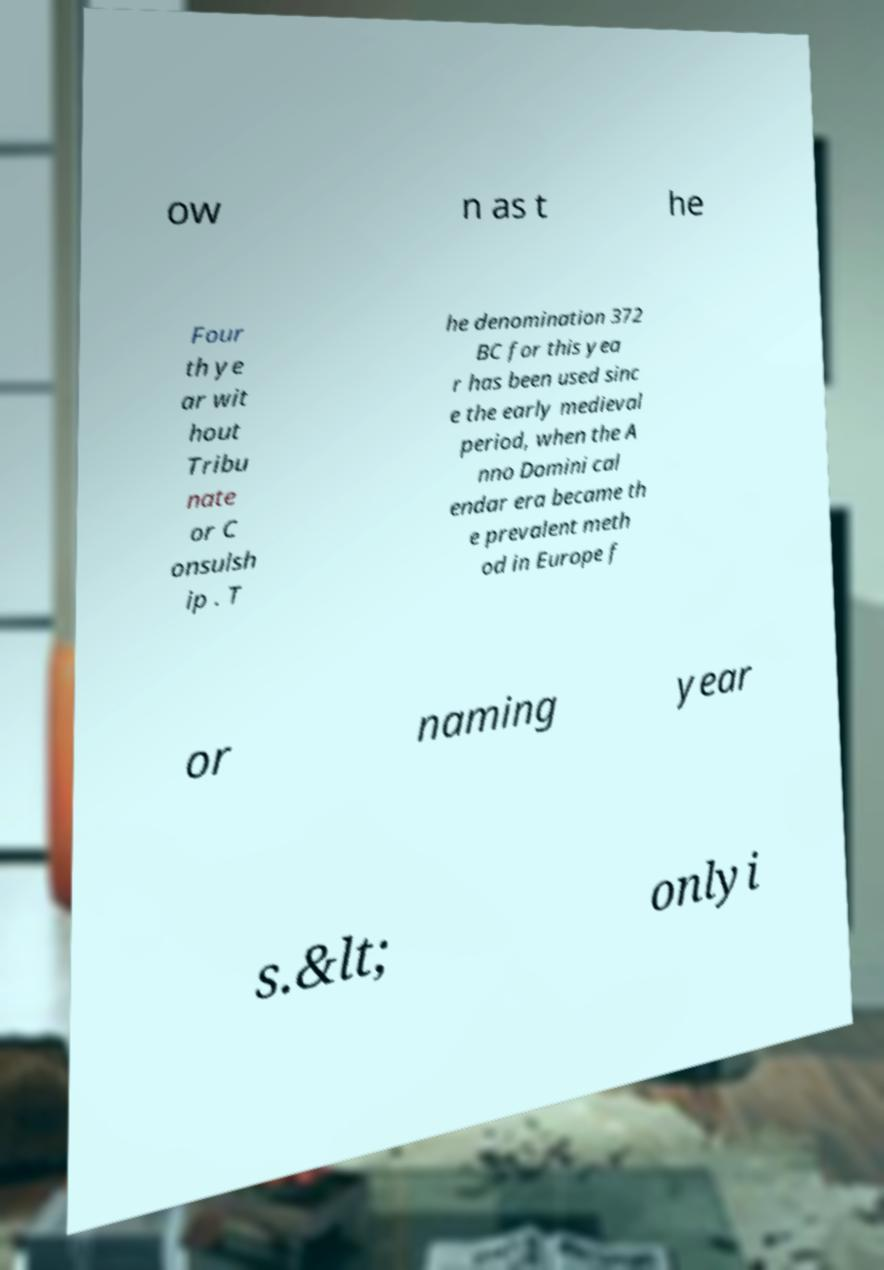I need the written content from this picture converted into text. Can you do that? ow n as t he Four th ye ar wit hout Tribu nate or C onsulsh ip . T he denomination 372 BC for this yea r has been used sinc e the early medieval period, when the A nno Domini cal endar era became th e prevalent meth od in Europe f or naming year s.&lt; onlyi 